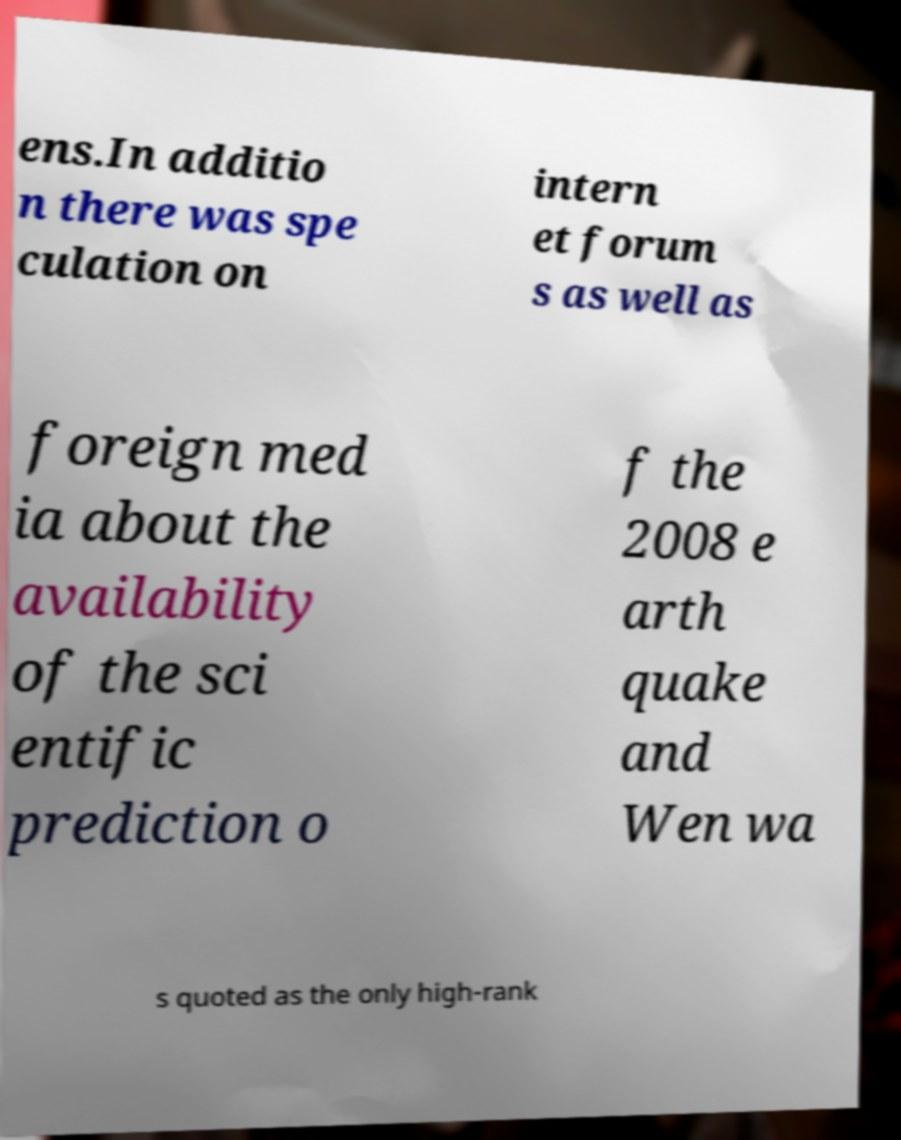Could you extract and type out the text from this image? ens.In additio n there was spe culation on intern et forum s as well as foreign med ia about the availability of the sci entific prediction o f the 2008 e arth quake and Wen wa s quoted as the only high-rank 